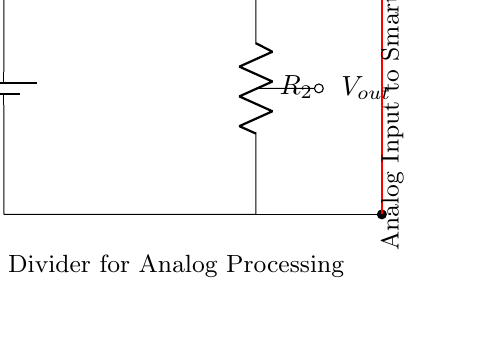What is the input voltage in the circuit? The input voltage, denoted as V_in, is indicated by the battery symbol at the left side of the circuit.
Answer: V_in What are the resistors labeled in the circuit? The circuit diagram shows two resistors labeled R_1 and R_2, positioned vertically, with R_1 at the top and R_2 below it.
Answer: R_1 and R_2 What is the output voltage mathematically represented as? The output voltage is represented as V_out, which is connected from the junction between R_1 and R_2, showcasing where the voltage is measured.
Answer: V_out What is the purpose of the voltage divider in this circuit? The function of the voltage divider is to reduce the input voltage into a smaller output voltage, which is crucial for analog processing in smartphone applications.
Answer: Analog processing How does the output voltage relate to the input voltage in this circuit? The output voltage V_out can be calculated based on the resistor values R_1 and R_2 through the voltage divider rule, which states that V_out = V_in * (R_2 / (R_1 + R_2)). Thus, it shows that V_out is a fraction of V_in depending on the resistance values.
Answer: V_out = V_in * (R_2 / (R_1 + R_2)) What happens to V_out if R_1 is increased? If R_1 is increased while keeping R_2 constant, the output voltage V_out will decrease because a larger proportion of V_in will drop across R_1 compared to R_2.
Answer: V_out decreases What is the significance of the red line in the circuit diagram? The red line indicates the path to the analog input of the smartphone, signifying where the processed voltage from the divider circuit is sent for further analysis or use.
Answer: Analog Input to Smartphone 